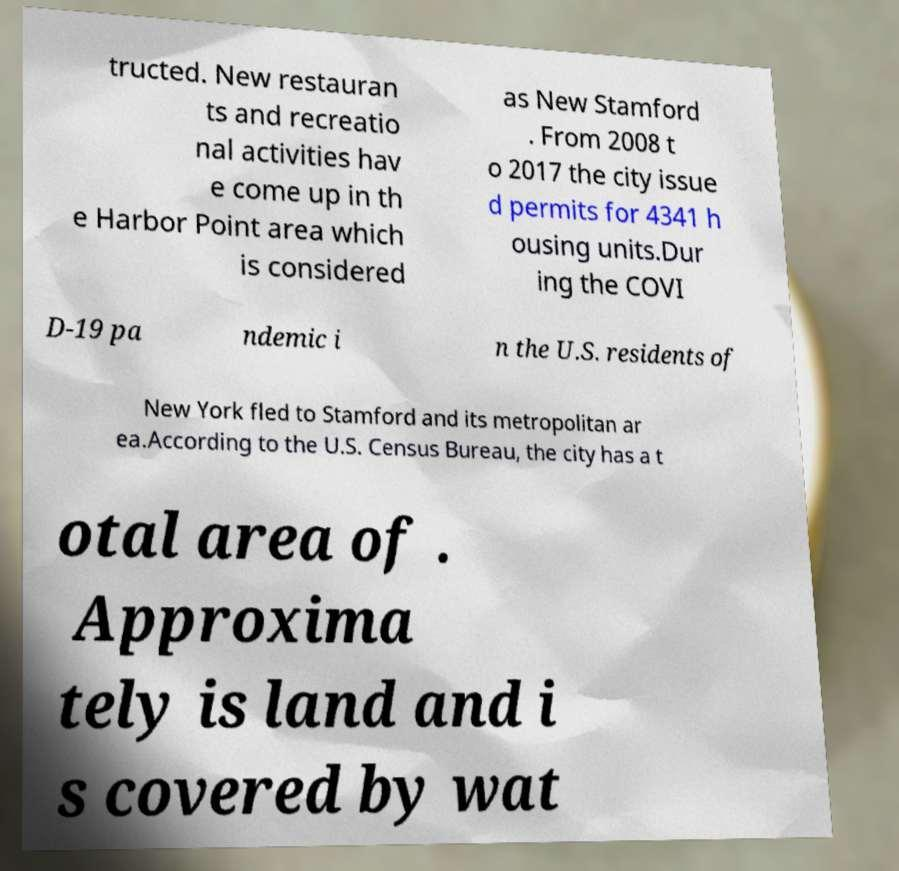For documentation purposes, I need the text within this image transcribed. Could you provide that? tructed. New restauran ts and recreatio nal activities hav e come up in th e Harbor Point area which is considered as New Stamford . From 2008 t o 2017 the city issue d permits for 4341 h ousing units.Dur ing the COVI D-19 pa ndemic i n the U.S. residents of New York fled to Stamford and its metropolitan ar ea.According to the U.S. Census Bureau, the city has a t otal area of . Approxima tely is land and i s covered by wat 